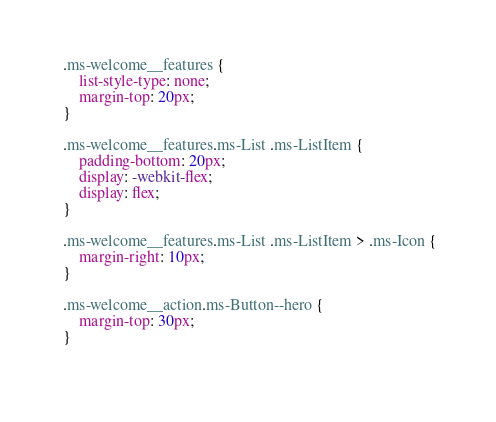<code> <loc_0><loc_0><loc_500><loc_500><_CSS_> .ms-welcome__features {
     list-style-type: none;
     margin-top: 20px;
 }
 
 .ms-welcome__features.ms-List .ms-ListItem {
     padding-bottom: 20px;
     display: -webkit-flex;
     display: flex;
 }
 
 .ms-welcome__features.ms-List .ms-ListItem > .ms-Icon {
     margin-right: 10px;
 }
 
 .ms-welcome__action.ms-Button--hero {
     margin-top: 30px;
 }
 </code> 